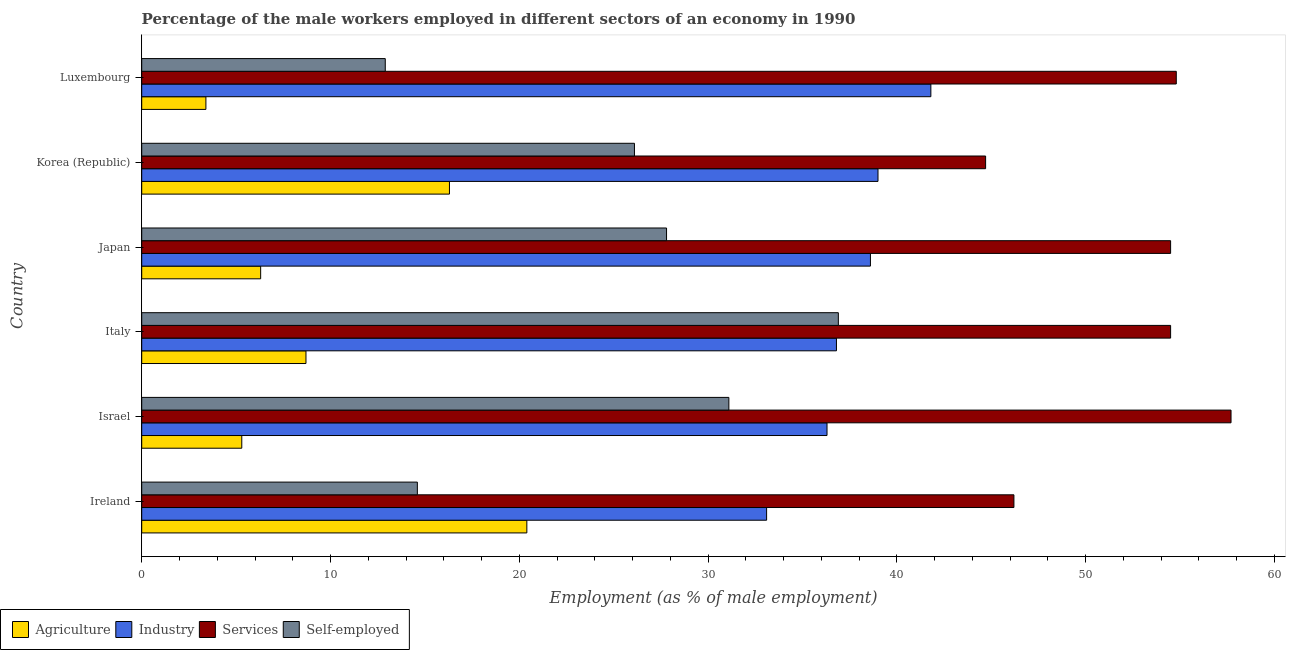How many different coloured bars are there?
Ensure brevity in your answer.  4. Are the number of bars per tick equal to the number of legend labels?
Your answer should be very brief. Yes. How many bars are there on the 2nd tick from the top?
Your answer should be compact. 4. What is the label of the 5th group of bars from the top?
Offer a very short reply. Israel. In how many cases, is the number of bars for a given country not equal to the number of legend labels?
Keep it short and to the point. 0. What is the percentage of male workers in agriculture in Ireland?
Your response must be concise. 20.4. Across all countries, what is the maximum percentage of male workers in services?
Provide a succinct answer. 57.7. Across all countries, what is the minimum percentage of male workers in agriculture?
Your answer should be compact. 3.4. In which country was the percentage of male workers in services maximum?
Keep it short and to the point. Israel. In which country was the percentage of male workers in agriculture minimum?
Your answer should be compact. Luxembourg. What is the total percentage of male workers in services in the graph?
Provide a succinct answer. 312.4. What is the difference between the percentage of male workers in industry in Korea (Republic) and the percentage of male workers in services in Ireland?
Your response must be concise. -7.2. What is the average percentage of male workers in services per country?
Give a very brief answer. 52.07. What is the difference between the percentage of male workers in services and percentage of self employed male workers in Ireland?
Your answer should be very brief. 31.6. In how many countries, is the percentage of male workers in industry greater than 4 %?
Offer a terse response. 6. Is the percentage of male workers in agriculture in Japan less than that in Korea (Republic)?
Provide a short and direct response. Yes. Is the difference between the percentage of male workers in agriculture in Italy and Luxembourg greater than the difference between the percentage of male workers in services in Italy and Luxembourg?
Keep it short and to the point. Yes. Is the sum of the percentage of male workers in industry in Israel and Luxembourg greater than the maximum percentage of self employed male workers across all countries?
Ensure brevity in your answer.  Yes. What does the 2nd bar from the top in Israel represents?
Make the answer very short. Services. What does the 4th bar from the bottom in Italy represents?
Offer a very short reply. Self-employed. Is it the case that in every country, the sum of the percentage of male workers in agriculture and percentage of male workers in industry is greater than the percentage of male workers in services?
Your response must be concise. No. How many countries are there in the graph?
Make the answer very short. 6. What is the difference between two consecutive major ticks on the X-axis?
Offer a terse response. 10. Are the values on the major ticks of X-axis written in scientific E-notation?
Give a very brief answer. No. Does the graph contain any zero values?
Provide a short and direct response. No. Does the graph contain grids?
Make the answer very short. No. Where does the legend appear in the graph?
Offer a terse response. Bottom left. What is the title of the graph?
Your answer should be very brief. Percentage of the male workers employed in different sectors of an economy in 1990. What is the label or title of the X-axis?
Your answer should be very brief. Employment (as % of male employment). What is the Employment (as % of male employment) in Agriculture in Ireland?
Offer a very short reply. 20.4. What is the Employment (as % of male employment) in Industry in Ireland?
Offer a very short reply. 33.1. What is the Employment (as % of male employment) of Services in Ireland?
Provide a succinct answer. 46.2. What is the Employment (as % of male employment) of Self-employed in Ireland?
Your answer should be very brief. 14.6. What is the Employment (as % of male employment) in Agriculture in Israel?
Your answer should be compact. 5.3. What is the Employment (as % of male employment) in Industry in Israel?
Ensure brevity in your answer.  36.3. What is the Employment (as % of male employment) of Services in Israel?
Your answer should be compact. 57.7. What is the Employment (as % of male employment) in Self-employed in Israel?
Provide a succinct answer. 31.1. What is the Employment (as % of male employment) of Agriculture in Italy?
Provide a succinct answer. 8.7. What is the Employment (as % of male employment) of Industry in Italy?
Your answer should be compact. 36.8. What is the Employment (as % of male employment) of Services in Italy?
Offer a terse response. 54.5. What is the Employment (as % of male employment) of Self-employed in Italy?
Provide a succinct answer. 36.9. What is the Employment (as % of male employment) of Agriculture in Japan?
Give a very brief answer. 6.3. What is the Employment (as % of male employment) of Industry in Japan?
Give a very brief answer. 38.6. What is the Employment (as % of male employment) in Services in Japan?
Keep it short and to the point. 54.5. What is the Employment (as % of male employment) in Self-employed in Japan?
Offer a terse response. 27.8. What is the Employment (as % of male employment) of Agriculture in Korea (Republic)?
Provide a short and direct response. 16.3. What is the Employment (as % of male employment) of Services in Korea (Republic)?
Your response must be concise. 44.7. What is the Employment (as % of male employment) of Self-employed in Korea (Republic)?
Your response must be concise. 26.1. What is the Employment (as % of male employment) of Agriculture in Luxembourg?
Offer a very short reply. 3.4. What is the Employment (as % of male employment) of Industry in Luxembourg?
Provide a succinct answer. 41.8. What is the Employment (as % of male employment) of Services in Luxembourg?
Give a very brief answer. 54.8. What is the Employment (as % of male employment) of Self-employed in Luxembourg?
Provide a short and direct response. 12.9. Across all countries, what is the maximum Employment (as % of male employment) of Agriculture?
Your answer should be very brief. 20.4. Across all countries, what is the maximum Employment (as % of male employment) in Industry?
Keep it short and to the point. 41.8. Across all countries, what is the maximum Employment (as % of male employment) in Services?
Your answer should be very brief. 57.7. Across all countries, what is the maximum Employment (as % of male employment) of Self-employed?
Your answer should be very brief. 36.9. Across all countries, what is the minimum Employment (as % of male employment) of Agriculture?
Give a very brief answer. 3.4. Across all countries, what is the minimum Employment (as % of male employment) of Industry?
Your response must be concise. 33.1. Across all countries, what is the minimum Employment (as % of male employment) of Services?
Offer a terse response. 44.7. Across all countries, what is the minimum Employment (as % of male employment) of Self-employed?
Your answer should be very brief. 12.9. What is the total Employment (as % of male employment) in Agriculture in the graph?
Provide a short and direct response. 60.4. What is the total Employment (as % of male employment) in Industry in the graph?
Give a very brief answer. 225.6. What is the total Employment (as % of male employment) of Services in the graph?
Your answer should be compact. 312.4. What is the total Employment (as % of male employment) of Self-employed in the graph?
Provide a succinct answer. 149.4. What is the difference between the Employment (as % of male employment) in Agriculture in Ireland and that in Israel?
Offer a terse response. 15.1. What is the difference between the Employment (as % of male employment) in Industry in Ireland and that in Israel?
Your answer should be compact. -3.2. What is the difference between the Employment (as % of male employment) in Self-employed in Ireland and that in Israel?
Give a very brief answer. -16.5. What is the difference between the Employment (as % of male employment) of Agriculture in Ireland and that in Italy?
Keep it short and to the point. 11.7. What is the difference between the Employment (as % of male employment) of Services in Ireland and that in Italy?
Your answer should be very brief. -8.3. What is the difference between the Employment (as % of male employment) in Self-employed in Ireland and that in Italy?
Keep it short and to the point. -22.3. What is the difference between the Employment (as % of male employment) in Industry in Ireland and that in Japan?
Provide a succinct answer. -5.5. What is the difference between the Employment (as % of male employment) of Self-employed in Ireland and that in Japan?
Keep it short and to the point. -13.2. What is the difference between the Employment (as % of male employment) of Services in Ireland and that in Korea (Republic)?
Your response must be concise. 1.5. What is the difference between the Employment (as % of male employment) in Agriculture in Ireland and that in Luxembourg?
Your answer should be very brief. 17. What is the difference between the Employment (as % of male employment) in Industry in Ireland and that in Luxembourg?
Your answer should be compact. -8.7. What is the difference between the Employment (as % of male employment) in Agriculture in Israel and that in Italy?
Provide a short and direct response. -3.4. What is the difference between the Employment (as % of male employment) in Industry in Israel and that in Japan?
Offer a terse response. -2.3. What is the difference between the Employment (as % of male employment) in Industry in Israel and that in Korea (Republic)?
Your answer should be compact. -2.7. What is the difference between the Employment (as % of male employment) of Services in Israel and that in Korea (Republic)?
Offer a terse response. 13. What is the difference between the Employment (as % of male employment) in Industry in Israel and that in Luxembourg?
Your answer should be compact. -5.5. What is the difference between the Employment (as % of male employment) in Agriculture in Italy and that in Japan?
Offer a very short reply. 2.4. What is the difference between the Employment (as % of male employment) in Services in Italy and that in Japan?
Provide a short and direct response. 0. What is the difference between the Employment (as % of male employment) in Agriculture in Italy and that in Korea (Republic)?
Give a very brief answer. -7.6. What is the difference between the Employment (as % of male employment) of Self-employed in Italy and that in Korea (Republic)?
Your answer should be very brief. 10.8. What is the difference between the Employment (as % of male employment) of Industry in Italy and that in Luxembourg?
Offer a terse response. -5. What is the difference between the Employment (as % of male employment) of Self-employed in Italy and that in Luxembourg?
Give a very brief answer. 24. What is the difference between the Employment (as % of male employment) of Agriculture in Japan and that in Korea (Republic)?
Your response must be concise. -10. What is the difference between the Employment (as % of male employment) of Industry in Japan and that in Korea (Republic)?
Provide a succinct answer. -0.4. What is the difference between the Employment (as % of male employment) in Self-employed in Japan and that in Korea (Republic)?
Make the answer very short. 1.7. What is the difference between the Employment (as % of male employment) in Agriculture in Japan and that in Luxembourg?
Make the answer very short. 2.9. What is the difference between the Employment (as % of male employment) of Industry in Japan and that in Luxembourg?
Offer a very short reply. -3.2. What is the difference between the Employment (as % of male employment) in Services in Japan and that in Luxembourg?
Your response must be concise. -0.3. What is the difference between the Employment (as % of male employment) of Self-employed in Japan and that in Luxembourg?
Offer a terse response. 14.9. What is the difference between the Employment (as % of male employment) in Agriculture in Korea (Republic) and that in Luxembourg?
Provide a succinct answer. 12.9. What is the difference between the Employment (as % of male employment) in Industry in Korea (Republic) and that in Luxembourg?
Provide a short and direct response. -2.8. What is the difference between the Employment (as % of male employment) of Services in Korea (Republic) and that in Luxembourg?
Offer a terse response. -10.1. What is the difference between the Employment (as % of male employment) in Self-employed in Korea (Republic) and that in Luxembourg?
Give a very brief answer. 13.2. What is the difference between the Employment (as % of male employment) of Agriculture in Ireland and the Employment (as % of male employment) of Industry in Israel?
Provide a succinct answer. -15.9. What is the difference between the Employment (as % of male employment) in Agriculture in Ireland and the Employment (as % of male employment) in Services in Israel?
Your response must be concise. -37.3. What is the difference between the Employment (as % of male employment) in Agriculture in Ireland and the Employment (as % of male employment) in Self-employed in Israel?
Your answer should be very brief. -10.7. What is the difference between the Employment (as % of male employment) of Industry in Ireland and the Employment (as % of male employment) of Services in Israel?
Your answer should be very brief. -24.6. What is the difference between the Employment (as % of male employment) in Industry in Ireland and the Employment (as % of male employment) in Self-employed in Israel?
Your answer should be compact. 2. What is the difference between the Employment (as % of male employment) of Services in Ireland and the Employment (as % of male employment) of Self-employed in Israel?
Offer a terse response. 15.1. What is the difference between the Employment (as % of male employment) in Agriculture in Ireland and the Employment (as % of male employment) in Industry in Italy?
Provide a short and direct response. -16.4. What is the difference between the Employment (as % of male employment) of Agriculture in Ireland and the Employment (as % of male employment) of Services in Italy?
Give a very brief answer. -34.1. What is the difference between the Employment (as % of male employment) of Agriculture in Ireland and the Employment (as % of male employment) of Self-employed in Italy?
Your answer should be very brief. -16.5. What is the difference between the Employment (as % of male employment) of Industry in Ireland and the Employment (as % of male employment) of Services in Italy?
Keep it short and to the point. -21.4. What is the difference between the Employment (as % of male employment) in Industry in Ireland and the Employment (as % of male employment) in Self-employed in Italy?
Your response must be concise. -3.8. What is the difference between the Employment (as % of male employment) of Agriculture in Ireland and the Employment (as % of male employment) of Industry in Japan?
Your response must be concise. -18.2. What is the difference between the Employment (as % of male employment) of Agriculture in Ireland and the Employment (as % of male employment) of Services in Japan?
Your response must be concise. -34.1. What is the difference between the Employment (as % of male employment) in Agriculture in Ireland and the Employment (as % of male employment) in Self-employed in Japan?
Ensure brevity in your answer.  -7.4. What is the difference between the Employment (as % of male employment) of Industry in Ireland and the Employment (as % of male employment) of Services in Japan?
Your answer should be compact. -21.4. What is the difference between the Employment (as % of male employment) in Services in Ireland and the Employment (as % of male employment) in Self-employed in Japan?
Provide a succinct answer. 18.4. What is the difference between the Employment (as % of male employment) in Agriculture in Ireland and the Employment (as % of male employment) in Industry in Korea (Republic)?
Your answer should be very brief. -18.6. What is the difference between the Employment (as % of male employment) of Agriculture in Ireland and the Employment (as % of male employment) of Services in Korea (Republic)?
Give a very brief answer. -24.3. What is the difference between the Employment (as % of male employment) in Industry in Ireland and the Employment (as % of male employment) in Self-employed in Korea (Republic)?
Provide a succinct answer. 7. What is the difference between the Employment (as % of male employment) of Services in Ireland and the Employment (as % of male employment) of Self-employed in Korea (Republic)?
Your answer should be compact. 20.1. What is the difference between the Employment (as % of male employment) of Agriculture in Ireland and the Employment (as % of male employment) of Industry in Luxembourg?
Ensure brevity in your answer.  -21.4. What is the difference between the Employment (as % of male employment) in Agriculture in Ireland and the Employment (as % of male employment) in Services in Luxembourg?
Make the answer very short. -34.4. What is the difference between the Employment (as % of male employment) of Agriculture in Ireland and the Employment (as % of male employment) of Self-employed in Luxembourg?
Give a very brief answer. 7.5. What is the difference between the Employment (as % of male employment) of Industry in Ireland and the Employment (as % of male employment) of Services in Luxembourg?
Provide a short and direct response. -21.7. What is the difference between the Employment (as % of male employment) in Industry in Ireland and the Employment (as % of male employment) in Self-employed in Luxembourg?
Make the answer very short. 20.2. What is the difference between the Employment (as % of male employment) of Services in Ireland and the Employment (as % of male employment) of Self-employed in Luxembourg?
Offer a very short reply. 33.3. What is the difference between the Employment (as % of male employment) in Agriculture in Israel and the Employment (as % of male employment) in Industry in Italy?
Ensure brevity in your answer.  -31.5. What is the difference between the Employment (as % of male employment) of Agriculture in Israel and the Employment (as % of male employment) of Services in Italy?
Provide a short and direct response. -49.2. What is the difference between the Employment (as % of male employment) in Agriculture in Israel and the Employment (as % of male employment) in Self-employed in Italy?
Your answer should be compact. -31.6. What is the difference between the Employment (as % of male employment) in Industry in Israel and the Employment (as % of male employment) in Services in Italy?
Keep it short and to the point. -18.2. What is the difference between the Employment (as % of male employment) in Industry in Israel and the Employment (as % of male employment) in Self-employed in Italy?
Keep it short and to the point. -0.6. What is the difference between the Employment (as % of male employment) of Services in Israel and the Employment (as % of male employment) of Self-employed in Italy?
Ensure brevity in your answer.  20.8. What is the difference between the Employment (as % of male employment) in Agriculture in Israel and the Employment (as % of male employment) in Industry in Japan?
Give a very brief answer. -33.3. What is the difference between the Employment (as % of male employment) in Agriculture in Israel and the Employment (as % of male employment) in Services in Japan?
Offer a very short reply. -49.2. What is the difference between the Employment (as % of male employment) of Agriculture in Israel and the Employment (as % of male employment) of Self-employed in Japan?
Your answer should be compact. -22.5. What is the difference between the Employment (as % of male employment) in Industry in Israel and the Employment (as % of male employment) in Services in Japan?
Offer a very short reply. -18.2. What is the difference between the Employment (as % of male employment) of Industry in Israel and the Employment (as % of male employment) of Self-employed in Japan?
Make the answer very short. 8.5. What is the difference between the Employment (as % of male employment) in Services in Israel and the Employment (as % of male employment) in Self-employed in Japan?
Your response must be concise. 29.9. What is the difference between the Employment (as % of male employment) in Agriculture in Israel and the Employment (as % of male employment) in Industry in Korea (Republic)?
Keep it short and to the point. -33.7. What is the difference between the Employment (as % of male employment) in Agriculture in Israel and the Employment (as % of male employment) in Services in Korea (Republic)?
Your answer should be very brief. -39.4. What is the difference between the Employment (as % of male employment) in Agriculture in Israel and the Employment (as % of male employment) in Self-employed in Korea (Republic)?
Your answer should be compact. -20.8. What is the difference between the Employment (as % of male employment) of Industry in Israel and the Employment (as % of male employment) of Services in Korea (Republic)?
Give a very brief answer. -8.4. What is the difference between the Employment (as % of male employment) in Services in Israel and the Employment (as % of male employment) in Self-employed in Korea (Republic)?
Your response must be concise. 31.6. What is the difference between the Employment (as % of male employment) of Agriculture in Israel and the Employment (as % of male employment) of Industry in Luxembourg?
Make the answer very short. -36.5. What is the difference between the Employment (as % of male employment) in Agriculture in Israel and the Employment (as % of male employment) in Services in Luxembourg?
Your answer should be very brief. -49.5. What is the difference between the Employment (as % of male employment) of Industry in Israel and the Employment (as % of male employment) of Services in Luxembourg?
Offer a terse response. -18.5. What is the difference between the Employment (as % of male employment) in Industry in Israel and the Employment (as % of male employment) in Self-employed in Luxembourg?
Offer a very short reply. 23.4. What is the difference between the Employment (as % of male employment) in Services in Israel and the Employment (as % of male employment) in Self-employed in Luxembourg?
Your response must be concise. 44.8. What is the difference between the Employment (as % of male employment) of Agriculture in Italy and the Employment (as % of male employment) of Industry in Japan?
Offer a terse response. -29.9. What is the difference between the Employment (as % of male employment) in Agriculture in Italy and the Employment (as % of male employment) in Services in Japan?
Give a very brief answer. -45.8. What is the difference between the Employment (as % of male employment) of Agriculture in Italy and the Employment (as % of male employment) of Self-employed in Japan?
Provide a short and direct response. -19.1. What is the difference between the Employment (as % of male employment) in Industry in Italy and the Employment (as % of male employment) in Services in Japan?
Your answer should be very brief. -17.7. What is the difference between the Employment (as % of male employment) of Services in Italy and the Employment (as % of male employment) of Self-employed in Japan?
Make the answer very short. 26.7. What is the difference between the Employment (as % of male employment) of Agriculture in Italy and the Employment (as % of male employment) of Industry in Korea (Republic)?
Provide a succinct answer. -30.3. What is the difference between the Employment (as % of male employment) of Agriculture in Italy and the Employment (as % of male employment) of Services in Korea (Republic)?
Your answer should be very brief. -36. What is the difference between the Employment (as % of male employment) in Agriculture in Italy and the Employment (as % of male employment) in Self-employed in Korea (Republic)?
Give a very brief answer. -17.4. What is the difference between the Employment (as % of male employment) in Industry in Italy and the Employment (as % of male employment) in Services in Korea (Republic)?
Keep it short and to the point. -7.9. What is the difference between the Employment (as % of male employment) in Services in Italy and the Employment (as % of male employment) in Self-employed in Korea (Republic)?
Offer a very short reply. 28.4. What is the difference between the Employment (as % of male employment) of Agriculture in Italy and the Employment (as % of male employment) of Industry in Luxembourg?
Ensure brevity in your answer.  -33.1. What is the difference between the Employment (as % of male employment) of Agriculture in Italy and the Employment (as % of male employment) of Services in Luxembourg?
Give a very brief answer. -46.1. What is the difference between the Employment (as % of male employment) of Industry in Italy and the Employment (as % of male employment) of Services in Luxembourg?
Provide a short and direct response. -18. What is the difference between the Employment (as % of male employment) in Industry in Italy and the Employment (as % of male employment) in Self-employed in Luxembourg?
Ensure brevity in your answer.  23.9. What is the difference between the Employment (as % of male employment) of Services in Italy and the Employment (as % of male employment) of Self-employed in Luxembourg?
Provide a short and direct response. 41.6. What is the difference between the Employment (as % of male employment) of Agriculture in Japan and the Employment (as % of male employment) of Industry in Korea (Republic)?
Offer a terse response. -32.7. What is the difference between the Employment (as % of male employment) in Agriculture in Japan and the Employment (as % of male employment) in Services in Korea (Republic)?
Provide a succinct answer. -38.4. What is the difference between the Employment (as % of male employment) in Agriculture in Japan and the Employment (as % of male employment) in Self-employed in Korea (Republic)?
Ensure brevity in your answer.  -19.8. What is the difference between the Employment (as % of male employment) of Services in Japan and the Employment (as % of male employment) of Self-employed in Korea (Republic)?
Keep it short and to the point. 28.4. What is the difference between the Employment (as % of male employment) of Agriculture in Japan and the Employment (as % of male employment) of Industry in Luxembourg?
Provide a succinct answer. -35.5. What is the difference between the Employment (as % of male employment) in Agriculture in Japan and the Employment (as % of male employment) in Services in Luxembourg?
Your answer should be very brief. -48.5. What is the difference between the Employment (as % of male employment) of Agriculture in Japan and the Employment (as % of male employment) of Self-employed in Luxembourg?
Offer a very short reply. -6.6. What is the difference between the Employment (as % of male employment) of Industry in Japan and the Employment (as % of male employment) of Services in Luxembourg?
Make the answer very short. -16.2. What is the difference between the Employment (as % of male employment) of Industry in Japan and the Employment (as % of male employment) of Self-employed in Luxembourg?
Keep it short and to the point. 25.7. What is the difference between the Employment (as % of male employment) of Services in Japan and the Employment (as % of male employment) of Self-employed in Luxembourg?
Make the answer very short. 41.6. What is the difference between the Employment (as % of male employment) of Agriculture in Korea (Republic) and the Employment (as % of male employment) of Industry in Luxembourg?
Your answer should be compact. -25.5. What is the difference between the Employment (as % of male employment) of Agriculture in Korea (Republic) and the Employment (as % of male employment) of Services in Luxembourg?
Ensure brevity in your answer.  -38.5. What is the difference between the Employment (as % of male employment) of Industry in Korea (Republic) and the Employment (as % of male employment) of Services in Luxembourg?
Give a very brief answer. -15.8. What is the difference between the Employment (as % of male employment) of Industry in Korea (Republic) and the Employment (as % of male employment) of Self-employed in Luxembourg?
Give a very brief answer. 26.1. What is the difference between the Employment (as % of male employment) in Services in Korea (Republic) and the Employment (as % of male employment) in Self-employed in Luxembourg?
Your answer should be compact. 31.8. What is the average Employment (as % of male employment) of Agriculture per country?
Provide a short and direct response. 10.07. What is the average Employment (as % of male employment) of Industry per country?
Offer a very short reply. 37.6. What is the average Employment (as % of male employment) in Services per country?
Ensure brevity in your answer.  52.07. What is the average Employment (as % of male employment) in Self-employed per country?
Provide a short and direct response. 24.9. What is the difference between the Employment (as % of male employment) in Agriculture and Employment (as % of male employment) in Industry in Ireland?
Make the answer very short. -12.7. What is the difference between the Employment (as % of male employment) of Agriculture and Employment (as % of male employment) of Services in Ireland?
Provide a short and direct response. -25.8. What is the difference between the Employment (as % of male employment) of Agriculture and Employment (as % of male employment) of Self-employed in Ireland?
Provide a short and direct response. 5.8. What is the difference between the Employment (as % of male employment) in Industry and Employment (as % of male employment) in Services in Ireland?
Offer a terse response. -13.1. What is the difference between the Employment (as % of male employment) in Services and Employment (as % of male employment) in Self-employed in Ireland?
Your answer should be very brief. 31.6. What is the difference between the Employment (as % of male employment) of Agriculture and Employment (as % of male employment) of Industry in Israel?
Your response must be concise. -31. What is the difference between the Employment (as % of male employment) in Agriculture and Employment (as % of male employment) in Services in Israel?
Offer a terse response. -52.4. What is the difference between the Employment (as % of male employment) in Agriculture and Employment (as % of male employment) in Self-employed in Israel?
Keep it short and to the point. -25.8. What is the difference between the Employment (as % of male employment) of Industry and Employment (as % of male employment) of Services in Israel?
Your answer should be compact. -21.4. What is the difference between the Employment (as % of male employment) of Services and Employment (as % of male employment) of Self-employed in Israel?
Make the answer very short. 26.6. What is the difference between the Employment (as % of male employment) of Agriculture and Employment (as % of male employment) of Industry in Italy?
Offer a very short reply. -28.1. What is the difference between the Employment (as % of male employment) of Agriculture and Employment (as % of male employment) of Services in Italy?
Your answer should be very brief. -45.8. What is the difference between the Employment (as % of male employment) of Agriculture and Employment (as % of male employment) of Self-employed in Italy?
Your answer should be very brief. -28.2. What is the difference between the Employment (as % of male employment) of Industry and Employment (as % of male employment) of Services in Italy?
Your answer should be compact. -17.7. What is the difference between the Employment (as % of male employment) in Agriculture and Employment (as % of male employment) in Industry in Japan?
Provide a succinct answer. -32.3. What is the difference between the Employment (as % of male employment) of Agriculture and Employment (as % of male employment) of Services in Japan?
Your answer should be very brief. -48.2. What is the difference between the Employment (as % of male employment) in Agriculture and Employment (as % of male employment) in Self-employed in Japan?
Your answer should be very brief. -21.5. What is the difference between the Employment (as % of male employment) in Industry and Employment (as % of male employment) in Services in Japan?
Make the answer very short. -15.9. What is the difference between the Employment (as % of male employment) of Services and Employment (as % of male employment) of Self-employed in Japan?
Your answer should be compact. 26.7. What is the difference between the Employment (as % of male employment) of Agriculture and Employment (as % of male employment) of Industry in Korea (Republic)?
Keep it short and to the point. -22.7. What is the difference between the Employment (as % of male employment) of Agriculture and Employment (as % of male employment) of Services in Korea (Republic)?
Ensure brevity in your answer.  -28.4. What is the difference between the Employment (as % of male employment) in Industry and Employment (as % of male employment) in Services in Korea (Republic)?
Your response must be concise. -5.7. What is the difference between the Employment (as % of male employment) of Agriculture and Employment (as % of male employment) of Industry in Luxembourg?
Your answer should be very brief. -38.4. What is the difference between the Employment (as % of male employment) of Agriculture and Employment (as % of male employment) of Services in Luxembourg?
Keep it short and to the point. -51.4. What is the difference between the Employment (as % of male employment) of Agriculture and Employment (as % of male employment) of Self-employed in Luxembourg?
Provide a short and direct response. -9.5. What is the difference between the Employment (as % of male employment) in Industry and Employment (as % of male employment) in Services in Luxembourg?
Provide a short and direct response. -13. What is the difference between the Employment (as % of male employment) of Industry and Employment (as % of male employment) of Self-employed in Luxembourg?
Ensure brevity in your answer.  28.9. What is the difference between the Employment (as % of male employment) in Services and Employment (as % of male employment) in Self-employed in Luxembourg?
Offer a very short reply. 41.9. What is the ratio of the Employment (as % of male employment) in Agriculture in Ireland to that in Israel?
Your answer should be compact. 3.85. What is the ratio of the Employment (as % of male employment) in Industry in Ireland to that in Israel?
Provide a succinct answer. 0.91. What is the ratio of the Employment (as % of male employment) of Services in Ireland to that in Israel?
Your response must be concise. 0.8. What is the ratio of the Employment (as % of male employment) in Self-employed in Ireland to that in Israel?
Provide a short and direct response. 0.47. What is the ratio of the Employment (as % of male employment) of Agriculture in Ireland to that in Italy?
Keep it short and to the point. 2.34. What is the ratio of the Employment (as % of male employment) of Industry in Ireland to that in Italy?
Ensure brevity in your answer.  0.9. What is the ratio of the Employment (as % of male employment) in Services in Ireland to that in Italy?
Offer a terse response. 0.85. What is the ratio of the Employment (as % of male employment) of Self-employed in Ireland to that in Italy?
Ensure brevity in your answer.  0.4. What is the ratio of the Employment (as % of male employment) of Agriculture in Ireland to that in Japan?
Your response must be concise. 3.24. What is the ratio of the Employment (as % of male employment) in Industry in Ireland to that in Japan?
Offer a very short reply. 0.86. What is the ratio of the Employment (as % of male employment) in Services in Ireland to that in Japan?
Keep it short and to the point. 0.85. What is the ratio of the Employment (as % of male employment) of Self-employed in Ireland to that in Japan?
Your answer should be compact. 0.53. What is the ratio of the Employment (as % of male employment) in Agriculture in Ireland to that in Korea (Republic)?
Keep it short and to the point. 1.25. What is the ratio of the Employment (as % of male employment) in Industry in Ireland to that in Korea (Republic)?
Give a very brief answer. 0.85. What is the ratio of the Employment (as % of male employment) in Services in Ireland to that in Korea (Republic)?
Provide a short and direct response. 1.03. What is the ratio of the Employment (as % of male employment) of Self-employed in Ireland to that in Korea (Republic)?
Your answer should be compact. 0.56. What is the ratio of the Employment (as % of male employment) in Industry in Ireland to that in Luxembourg?
Give a very brief answer. 0.79. What is the ratio of the Employment (as % of male employment) in Services in Ireland to that in Luxembourg?
Give a very brief answer. 0.84. What is the ratio of the Employment (as % of male employment) in Self-employed in Ireland to that in Luxembourg?
Your response must be concise. 1.13. What is the ratio of the Employment (as % of male employment) of Agriculture in Israel to that in Italy?
Ensure brevity in your answer.  0.61. What is the ratio of the Employment (as % of male employment) of Industry in Israel to that in Italy?
Make the answer very short. 0.99. What is the ratio of the Employment (as % of male employment) in Services in Israel to that in Italy?
Keep it short and to the point. 1.06. What is the ratio of the Employment (as % of male employment) in Self-employed in Israel to that in Italy?
Keep it short and to the point. 0.84. What is the ratio of the Employment (as % of male employment) of Agriculture in Israel to that in Japan?
Provide a succinct answer. 0.84. What is the ratio of the Employment (as % of male employment) in Industry in Israel to that in Japan?
Your answer should be very brief. 0.94. What is the ratio of the Employment (as % of male employment) in Services in Israel to that in Japan?
Ensure brevity in your answer.  1.06. What is the ratio of the Employment (as % of male employment) in Self-employed in Israel to that in Japan?
Give a very brief answer. 1.12. What is the ratio of the Employment (as % of male employment) of Agriculture in Israel to that in Korea (Republic)?
Offer a terse response. 0.33. What is the ratio of the Employment (as % of male employment) in Industry in Israel to that in Korea (Republic)?
Give a very brief answer. 0.93. What is the ratio of the Employment (as % of male employment) in Services in Israel to that in Korea (Republic)?
Your answer should be compact. 1.29. What is the ratio of the Employment (as % of male employment) of Self-employed in Israel to that in Korea (Republic)?
Offer a very short reply. 1.19. What is the ratio of the Employment (as % of male employment) in Agriculture in Israel to that in Luxembourg?
Ensure brevity in your answer.  1.56. What is the ratio of the Employment (as % of male employment) of Industry in Israel to that in Luxembourg?
Make the answer very short. 0.87. What is the ratio of the Employment (as % of male employment) in Services in Israel to that in Luxembourg?
Your answer should be very brief. 1.05. What is the ratio of the Employment (as % of male employment) in Self-employed in Israel to that in Luxembourg?
Offer a very short reply. 2.41. What is the ratio of the Employment (as % of male employment) in Agriculture in Italy to that in Japan?
Your response must be concise. 1.38. What is the ratio of the Employment (as % of male employment) of Industry in Italy to that in Japan?
Your answer should be very brief. 0.95. What is the ratio of the Employment (as % of male employment) in Services in Italy to that in Japan?
Offer a terse response. 1. What is the ratio of the Employment (as % of male employment) in Self-employed in Italy to that in Japan?
Make the answer very short. 1.33. What is the ratio of the Employment (as % of male employment) of Agriculture in Italy to that in Korea (Republic)?
Offer a very short reply. 0.53. What is the ratio of the Employment (as % of male employment) of Industry in Italy to that in Korea (Republic)?
Make the answer very short. 0.94. What is the ratio of the Employment (as % of male employment) in Services in Italy to that in Korea (Republic)?
Ensure brevity in your answer.  1.22. What is the ratio of the Employment (as % of male employment) in Self-employed in Italy to that in Korea (Republic)?
Your answer should be compact. 1.41. What is the ratio of the Employment (as % of male employment) in Agriculture in Italy to that in Luxembourg?
Provide a short and direct response. 2.56. What is the ratio of the Employment (as % of male employment) in Industry in Italy to that in Luxembourg?
Give a very brief answer. 0.88. What is the ratio of the Employment (as % of male employment) of Self-employed in Italy to that in Luxembourg?
Provide a succinct answer. 2.86. What is the ratio of the Employment (as % of male employment) of Agriculture in Japan to that in Korea (Republic)?
Your response must be concise. 0.39. What is the ratio of the Employment (as % of male employment) of Services in Japan to that in Korea (Republic)?
Provide a succinct answer. 1.22. What is the ratio of the Employment (as % of male employment) of Self-employed in Japan to that in Korea (Republic)?
Your answer should be very brief. 1.07. What is the ratio of the Employment (as % of male employment) in Agriculture in Japan to that in Luxembourg?
Ensure brevity in your answer.  1.85. What is the ratio of the Employment (as % of male employment) of Industry in Japan to that in Luxembourg?
Your answer should be very brief. 0.92. What is the ratio of the Employment (as % of male employment) of Self-employed in Japan to that in Luxembourg?
Your answer should be very brief. 2.15. What is the ratio of the Employment (as % of male employment) of Agriculture in Korea (Republic) to that in Luxembourg?
Your answer should be very brief. 4.79. What is the ratio of the Employment (as % of male employment) of Industry in Korea (Republic) to that in Luxembourg?
Ensure brevity in your answer.  0.93. What is the ratio of the Employment (as % of male employment) in Services in Korea (Republic) to that in Luxembourg?
Offer a very short reply. 0.82. What is the ratio of the Employment (as % of male employment) of Self-employed in Korea (Republic) to that in Luxembourg?
Provide a succinct answer. 2.02. What is the difference between the highest and the second highest Employment (as % of male employment) of Agriculture?
Keep it short and to the point. 4.1. What is the difference between the highest and the second highest Employment (as % of male employment) of Services?
Make the answer very short. 2.9. What is the difference between the highest and the lowest Employment (as % of male employment) of Agriculture?
Your response must be concise. 17. What is the difference between the highest and the lowest Employment (as % of male employment) in Industry?
Make the answer very short. 8.7. What is the difference between the highest and the lowest Employment (as % of male employment) in Self-employed?
Offer a terse response. 24. 